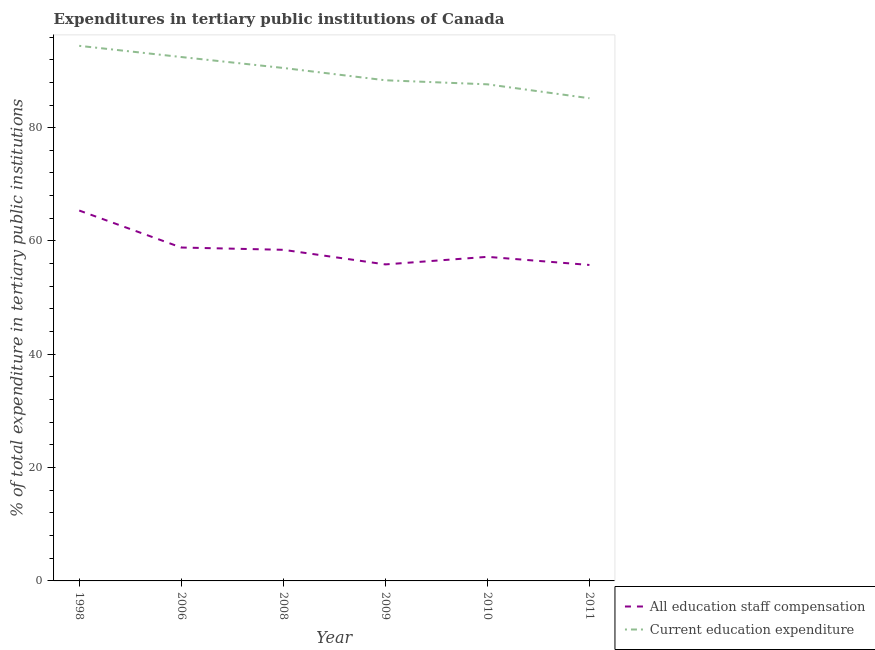Does the line corresponding to expenditure in staff compensation intersect with the line corresponding to expenditure in education?
Give a very brief answer. No. What is the expenditure in staff compensation in 2011?
Ensure brevity in your answer.  55.77. Across all years, what is the maximum expenditure in staff compensation?
Provide a succinct answer. 65.38. Across all years, what is the minimum expenditure in staff compensation?
Your answer should be compact. 55.77. In which year was the expenditure in education minimum?
Your response must be concise. 2011. What is the total expenditure in staff compensation in the graph?
Offer a very short reply. 351.5. What is the difference between the expenditure in staff compensation in 2006 and that in 2010?
Keep it short and to the point. 1.64. What is the difference between the expenditure in staff compensation in 1998 and the expenditure in education in 2010?
Provide a succinct answer. -22.27. What is the average expenditure in staff compensation per year?
Give a very brief answer. 58.58. In the year 2011, what is the difference between the expenditure in education and expenditure in staff compensation?
Offer a very short reply. 29.43. What is the ratio of the expenditure in education in 1998 to that in 2008?
Keep it short and to the point. 1.04. Is the expenditure in staff compensation in 2006 less than that in 2011?
Make the answer very short. No. What is the difference between the highest and the second highest expenditure in education?
Your response must be concise. 1.98. What is the difference between the highest and the lowest expenditure in education?
Keep it short and to the point. 9.25. Is the sum of the expenditure in staff compensation in 2008 and 2010 greater than the maximum expenditure in education across all years?
Offer a terse response. Yes. Is the expenditure in staff compensation strictly greater than the expenditure in education over the years?
Ensure brevity in your answer.  No. Does the graph contain grids?
Keep it short and to the point. No. Where does the legend appear in the graph?
Ensure brevity in your answer.  Bottom right. What is the title of the graph?
Keep it short and to the point. Expenditures in tertiary public institutions of Canada. What is the label or title of the X-axis?
Make the answer very short. Year. What is the label or title of the Y-axis?
Your answer should be very brief. % of total expenditure in tertiary public institutions. What is the % of total expenditure in tertiary public institutions of All education staff compensation in 1998?
Ensure brevity in your answer.  65.38. What is the % of total expenditure in tertiary public institutions in Current education expenditure in 1998?
Ensure brevity in your answer.  94.44. What is the % of total expenditure in tertiary public institutions in All education staff compensation in 2006?
Offer a very short reply. 58.85. What is the % of total expenditure in tertiary public institutions of Current education expenditure in 2006?
Make the answer very short. 92.47. What is the % of total expenditure in tertiary public institutions in All education staff compensation in 2008?
Your answer should be very brief. 58.44. What is the % of total expenditure in tertiary public institutions in Current education expenditure in 2008?
Give a very brief answer. 90.54. What is the % of total expenditure in tertiary public institutions in All education staff compensation in 2009?
Make the answer very short. 55.87. What is the % of total expenditure in tertiary public institutions of Current education expenditure in 2009?
Your answer should be compact. 88.37. What is the % of total expenditure in tertiary public institutions of All education staff compensation in 2010?
Your answer should be very brief. 57.2. What is the % of total expenditure in tertiary public institutions in Current education expenditure in 2010?
Offer a very short reply. 87.65. What is the % of total expenditure in tertiary public institutions in All education staff compensation in 2011?
Your answer should be very brief. 55.77. What is the % of total expenditure in tertiary public institutions of Current education expenditure in 2011?
Provide a short and direct response. 85.2. Across all years, what is the maximum % of total expenditure in tertiary public institutions of All education staff compensation?
Ensure brevity in your answer.  65.38. Across all years, what is the maximum % of total expenditure in tertiary public institutions of Current education expenditure?
Your answer should be very brief. 94.44. Across all years, what is the minimum % of total expenditure in tertiary public institutions in All education staff compensation?
Your answer should be compact. 55.77. Across all years, what is the minimum % of total expenditure in tertiary public institutions of Current education expenditure?
Offer a terse response. 85.2. What is the total % of total expenditure in tertiary public institutions of All education staff compensation in the graph?
Provide a short and direct response. 351.5. What is the total % of total expenditure in tertiary public institutions in Current education expenditure in the graph?
Give a very brief answer. 538.66. What is the difference between the % of total expenditure in tertiary public institutions in All education staff compensation in 1998 and that in 2006?
Your response must be concise. 6.53. What is the difference between the % of total expenditure in tertiary public institutions of Current education expenditure in 1998 and that in 2006?
Provide a succinct answer. 1.98. What is the difference between the % of total expenditure in tertiary public institutions of All education staff compensation in 1998 and that in 2008?
Ensure brevity in your answer.  6.93. What is the difference between the % of total expenditure in tertiary public institutions in Current education expenditure in 1998 and that in 2008?
Your answer should be compact. 3.91. What is the difference between the % of total expenditure in tertiary public institutions of All education staff compensation in 1998 and that in 2009?
Offer a very short reply. 9.51. What is the difference between the % of total expenditure in tertiary public institutions of Current education expenditure in 1998 and that in 2009?
Offer a terse response. 6.08. What is the difference between the % of total expenditure in tertiary public institutions in All education staff compensation in 1998 and that in 2010?
Provide a succinct answer. 8.17. What is the difference between the % of total expenditure in tertiary public institutions of Current education expenditure in 1998 and that in 2010?
Provide a short and direct response. 6.79. What is the difference between the % of total expenditure in tertiary public institutions of All education staff compensation in 1998 and that in 2011?
Ensure brevity in your answer.  9.61. What is the difference between the % of total expenditure in tertiary public institutions of Current education expenditure in 1998 and that in 2011?
Give a very brief answer. 9.25. What is the difference between the % of total expenditure in tertiary public institutions of All education staff compensation in 2006 and that in 2008?
Provide a short and direct response. 0.4. What is the difference between the % of total expenditure in tertiary public institutions in Current education expenditure in 2006 and that in 2008?
Provide a succinct answer. 1.93. What is the difference between the % of total expenditure in tertiary public institutions in All education staff compensation in 2006 and that in 2009?
Give a very brief answer. 2.98. What is the difference between the % of total expenditure in tertiary public institutions in Current education expenditure in 2006 and that in 2009?
Give a very brief answer. 4.1. What is the difference between the % of total expenditure in tertiary public institutions in All education staff compensation in 2006 and that in 2010?
Provide a succinct answer. 1.64. What is the difference between the % of total expenditure in tertiary public institutions of Current education expenditure in 2006 and that in 2010?
Give a very brief answer. 4.82. What is the difference between the % of total expenditure in tertiary public institutions in All education staff compensation in 2006 and that in 2011?
Give a very brief answer. 3.08. What is the difference between the % of total expenditure in tertiary public institutions in Current education expenditure in 2006 and that in 2011?
Your answer should be very brief. 7.27. What is the difference between the % of total expenditure in tertiary public institutions of All education staff compensation in 2008 and that in 2009?
Give a very brief answer. 2.58. What is the difference between the % of total expenditure in tertiary public institutions of Current education expenditure in 2008 and that in 2009?
Your answer should be very brief. 2.17. What is the difference between the % of total expenditure in tertiary public institutions in All education staff compensation in 2008 and that in 2010?
Your answer should be compact. 1.24. What is the difference between the % of total expenditure in tertiary public institutions of Current education expenditure in 2008 and that in 2010?
Keep it short and to the point. 2.89. What is the difference between the % of total expenditure in tertiary public institutions of All education staff compensation in 2008 and that in 2011?
Ensure brevity in your answer.  2.67. What is the difference between the % of total expenditure in tertiary public institutions of Current education expenditure in 2008 and that in 2011?
Give a very brief answer. 5.34. What is the difference between the % of total expenditure in tertiary public institutions of All education staff compensation in 2009 and that in 2010?
Provide a succinct answer. -1.34. What is the difference between the % of total expenditure in tertiary public institutions in Current education expenditure in 2009 and that in 2010?
Ensure brevity in your answer.  0.71. What is the difference between the % of total expenditure in tertiary public institutions of All education staff compensation in 2009 and that in 2011?
Provide a succinct answer. 0.1. What is the difference between the % of total expenditure in tertiary public institutions in Current education expenditure in 2009 and that in 2011?
Your answer should be very brief. 3.17. What is the difference between the % of total expenditure in tertiary public institutions of All education staff compensation in 2010 and that in 2011?
Make the answer very short. 1.43. What is the difference between the % of total expenditure in tertiary public institutions of Current education expenditure in 2010 and that in 2011?
Keep it short and to the point. 2.45. What is the difference between the % of total expenditure in tertiary public institutions of All education staff compensation in 1998 and the % of total expenditure in tertiary public institutions of Current education expenditure in 2006?
Give a very brief answer. -27.09. What is the difference between the % of total expenditure in tertiary public institutions of All education staff compensation in 1998 and the % of total expenditure in tertiary public institutions of Current education expenditure in 2008?
Ensure brevity in your answer.  -25.16. What is the difference between the % of total expenditure in tertiary public institutions in All education staff compensation in 1998 and the % of total expenditure in tertiary public institutions in Current education expenditure in 2009?
Provide a short and direct response. -22.99. What is the difference between the % of total expenditure in tertiary public institutions of All education staff compensation in 1998 and the % of total expenditure in tertiary public institutions of Current education expenditure in 2010?
Offer a terse response. -22.27. What is the difference between the % of total expenditure in tertiary public institutions of All education staff compensation in 1998 and the % of total expenditure in tertiary public institutions of Current education expenditure in 2011?
Give a very brief answer. -19.82. What is the difference between the % of total expenditure in tertiary public institutions of All education staff compensation in 2006 and the % of total expenditure in tertiary public institutions of Current education expenditure in 2008?
Provide a short and direct response. -31.69. What is the difference between the % of total expenditure in tertiary public institutions in All education staff compensation in 2006 and the % of total expenditure in tertiary public institutions in Current education expenditure in 2009?
Your answer should be compact. -29.52. What is the difference between the % of total expenditure in tertiary public institutions in All education staff compensation in 2006 and the % of total expenditure in tertiary public institutions in Current education expenditure in 2010?
Your answer should be very brief. -28.81. What is the difference between the % of total expenditure in tertiary public institutions in All education staff compensation in 2006 and the % of total expenditure in tertiary public institutions in Current education expenditure in 2011?
Provide a short and direct response. -26.35. What is the difference between the % of total expenditure in tertiary public institutions of All education staff compensation in 2008 and the % of total expenditure in tertiary public institutions of Current education expenditure in 2009?
Ensure brevity in your answer.  -29.92. What is the difference between the % of total expenditure in tertiary public institutions in All education staff compensation in 2008 and the % of total expenditure in tertiary public institutions in Current education expenditure in 2010?
Give a very brief answer. -29.21. What is the difference between the % of total expenditure in tertiary public institutions of All education staff compensation in 2008 and the % of total expenditure in tertiary public institutions of Current education expenditure in 2011?
Your answer should be compact. -26.75. What is the difference between the % of total expenditure in tertiary public institutions of All education staff compensation in 2009 and the % of total expenditure in tertiary public institutions of Current education expenditure in 2010?
Your answer should be compact. -31.79. What is the difference between the % of total expenditure in tertiary public institutions in All education staff compensation in 2009 and the % of total expenditure in tertiary public institutions in Current education expenditure in 2011?
Ensure brevity in your answer.  -29.33. What is the difference between the % of total expenditure in tertiary public institutions of All education staff compensation in 2010 and the % of total expenditure in tertiary public institutions of Current education expenditure in 2011?
Offer a terse response. -27.99. What is the average % of total expenditure in tertiary public institutions of All education staff compensation per year?
Provide a succinct answer. 58.58. What is the average % of total expenditure in tertiary public institutions in Current education expenditure per year?
Offer a terse response. 89.78. In the year 1998, what is the difference between the % of total expenditure in tertiary public institutions in All education staff compensation and % of total expenditure in tertiary public institutions in Current education expenditure?
Your answer should be compact. -29.07. In the year 2006, what is the difference between the % of total expenditure in tertiary public institutions in All education staff compensation and % of total expenditure in tertiary public institutions in Current education expenditure?
Ensure brevity in your answer.  -33.62. In the year 2008, what is the difference between the % of total expenditure in tertiary public institutions in All education staff compensation and % of total expenditure in tertiary public institutions in Current education expenditure?
Make the answer very short. -32.1. In the year 2009, what is the difference between the % of total expenditure in tertiary public institutions of All education staff compensation and % of total expenditure in tertiary public institutions of Current education expenditure?
Provide a succinct answer. -32.5. In the year 2010, what is the difference between the % of total expenditure in tertiary public institutions in All education staff compensation and % of total expenditure in tertiary public institutions in Current education expenditure?
Your response must be concise. -30.45. In the year 2011, what is the difference between the % of total expenditure in tertiary public institutions in All education staff compensation and % of total expenditure in tertiary public institutions in Current education expenditure?
Your response must be concise. -29.43. What is the ratio of the % of total expenditure in tertiary public institutions of All education staff compensation in 1998 to that in 2006?
Make the answer very short. 1.11. What is the ratio of the % of total expenditure in tertiary public institutions in Current education expenditure in 1998 to that in 2006?
Keep it short and to the point. 1.02. What is the ratio of the % of total expenditure in tertiary public institutions in All education staff compensation in 1998 to that in 2008?
Give a very brief answer. 1.12. What is the ratio of the % of total expenditure in tertiary public institutions in Current education expenditure in 1998 to that in 2008?
Keep it short and to the point. 1.04. What is the ratio of the % of total expenditure in tertiary public institutions in All education staff compensation in 1998 to that in 2009?
Provide a succinct answer. 1.17. What is the ratio of the % of total expenditure in tertiary public institutions of Current education expenditure in 1998 to that in 2009?
Provide a succinct answer. 1.07. What is the ratio of the % of total expenditure in tertiary public institutions in Current education expenditure in 1998 to that in 2010?
Provide a short and direct response. 1.08. What is the ratio of the % of total expenditure in tertiary public institutions of All education staff compensation in 1998 to that in 2011?
Offer a terse response. 1.17. What is the ratio of the % of total expenditure in tertiary public institutions of Current education expenditure in 1998 to that in 2011?
Provide a succinct answer. 1.11. What is the ratio of the % of total expenditure in tertiary public institutions in All education staff compensation in 2006 to that in 2008?
Keep it short and to the point. 1.01. What is the ratio of the % of total expenditure in tertiary public institutions in Current education expenditure in 2006 to that in 2008?
Your response must be concise. 1.02. What is the ratio of the % of total expenditure in tertiary public institutions of All education staff compensation in 2006 to that in 2009?
Keep it short and to the point. 1.05. What is the ratio of the % of total expenditure in tertiary public institutions of Current education expenditure in 2006 to that in 2009?
Offer a very short reply. 1.05. What is the ratio of the % of total expenditure in tertiary public institutions of All education staff compensation in 2006 to that in 2010?
Your answer should be compact. 1.03. What is the ratio of the % of total expenditure in tertiary public institutions of Current education expenditure in 2006 to that in 2010?
Make the answer very short. 1.05. What is the ratio of the % of total expenditure in tertiary public institutions of All education staff compensation in 2006 to that in 2011?
Offer a very short reply. 1.06. What is the ratio of the % of total expenditure in tertiary public institutions in Current education expenditure in 2006 to that in 2011?
Provide a short and direct response. 1.09. What is the ratio of the % of total expenditure in tertiary public institutions in All education staff compensation in 2008 to that in 2009?
Make the answer very short. 1.05. What is the ratio of the % of total expenditure in tertiary public institutions in Current education expenditure in 2008 to that in 2009?
Offer a very short reply. 1.02. What is the ratio of the % of total expenditure in tertiary public institutions of All education staff compensation in 2008 to that in 2010?
Provide a succinct answer. 1.02. What is the ratio of the % of total expenditure in tertiary public institutions of Current education expenditure in 2008 to that in 2010?
Give a very brief answer. 1.03. What is the ratio of the % of total expenditure in tertiary public institutions in All education staff compensation in 2008 to that in 2011?
Make the answer very short. 1.05. What is the ratio of the % of total expenditure in tertiary public institutions of Current education expenditure in 2008 to that in 2011?
Your answer should be very brief. 1.06. What is the ratio of the % of total expenditure in tertiary public institutions of All education staff compensation in 2009 to that in 2010?
Keep it short and to the point. 0.98. What is the ratio of the % of total expenditure in tertiary public institutions of Current education expenditure in 2009 to that in 2010?
Your answer should be compact. 1.01. What is the ratio of the % of total expenditure in tertiary public institutions of Current education expenditure in 2009 to that in 2011?
Your answer should be very brief. 1.04. What is the ratio of the % of total expenditure in tertiary public institutions in All education staff compensation in 2010 to that in 2011?
Your answer should be compact. 1.03. What is the ratio of the % of total expenditure in tertiary public institutions in Current education expenditure in 2010 to that in 2011?
Offer a very short reply. 1.03. What is the difference between the highest and the second highest % of total expenditure in tertiary public institutions of All education staff compensation?
Provide a short and direct response. 6.53. What is the difference between the highest and the second highest % of total expenditure in tertiary public institutions in Current education expenditure?
Your answer should be very brief. 1.98. What is the difference between the highest and the lowest % of total expenditure in tertiary public institutions in All education staff compensation?
Provide a short and direct response. 9.61. What is the difference between the highest and the lowest % of total expenditure in tertiary public institutions of Current education expenditure?
Keep it short and to the point. 9.25. 